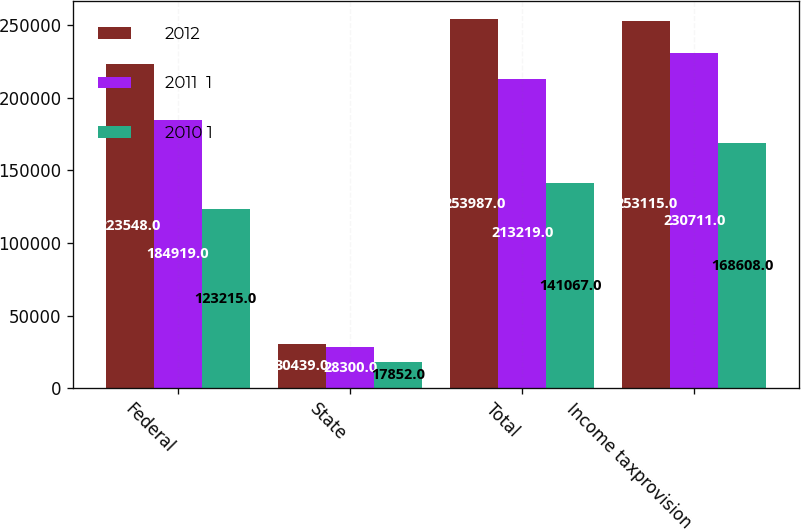<chart> <loc_0><loc_0><loc_500><loc_500><stacked_bar_chart><ecel><fcel>Federal<fcel>State<fcel>Total<fcel>Income taxprovision<nl><fcel>2012<fcel>223548<fcel>30439<fcel>253987<fcel>253115<nl><fcel>2011  1<fcel>184919<fcel>28300<fcel>213219<fcel>230711<nl><fcel>2010 1<fcel>123215<fcel>17852<fcel>141067<fcel>168608<nl></chart> 